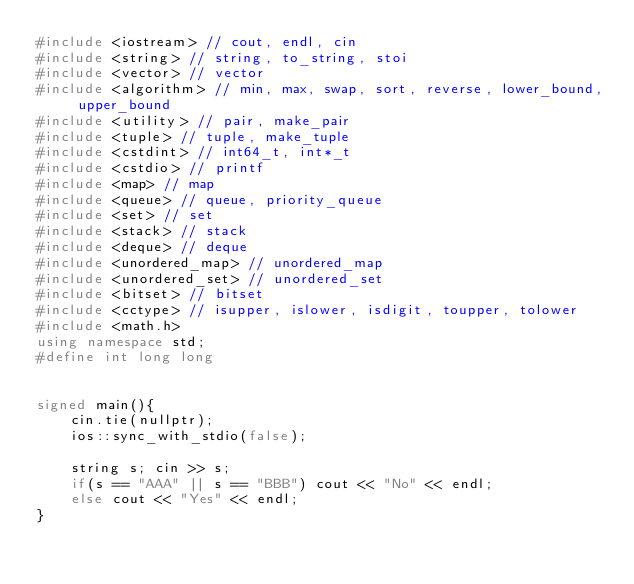<code> <loc_0><loc_0><loc_500><loc_500><_C++_>#include <iostream> // cout, endl, cin
#include <string> // string, to_string, stoi
#include <vector> // vector
#include <algorithm> // min, max, swap, sort, reverse, lower_bound, upper_bound
#include <utility> // pair, make_pair
#include <tuple> // tuple, make_tuple
#include <cstdint> // int64_t, int*_t
#include <cstdio> // printf
#include <map> // map
#include <queue> // queue, priority_queue
#include <set> // set
#include <stack> // stack
#include <deque> // deque
#include <unordered_map> // unordered_map
#include <unordered_set> // unordered_set
#include <bitset> // bitset
#include <cctype> // isupper, islower, isdigit, toupper, tolower
#include <math.h>
using namespace std;
#define int long long


signed main(){
    cin.tie(nullptr);
    ios::sync_with_stdio(false);

    string s; cin >> s;
    if(s == "AAA" || s == "BBB") cout << "No" << endl;
    else cout << "Yes" << endl;
}





</code> 